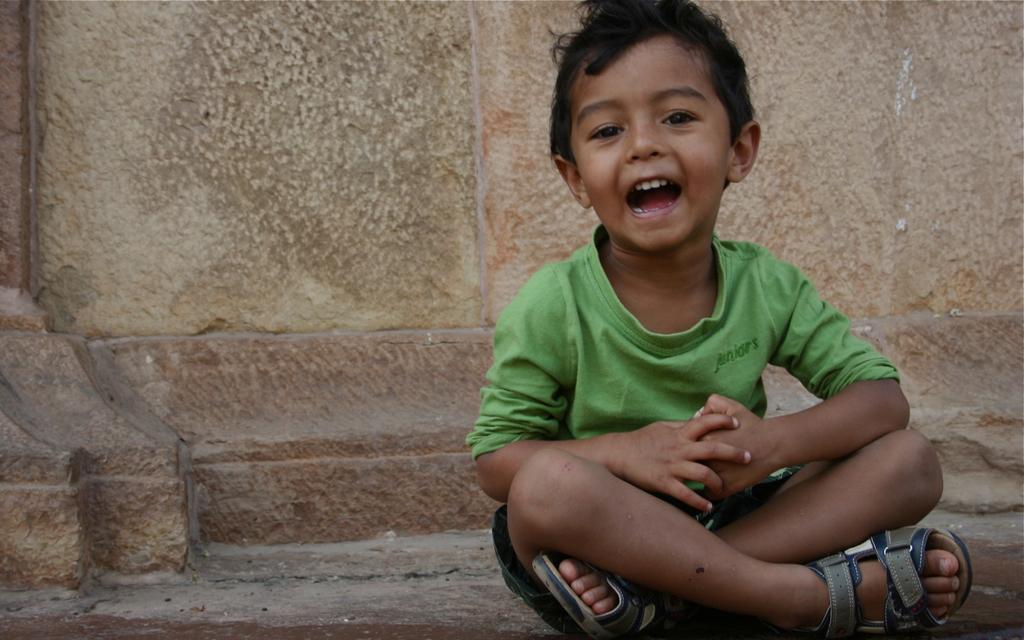Can you describe this image briefly? In the front of the image I can see a boy is sitting. In the background of the image there is a wall. 